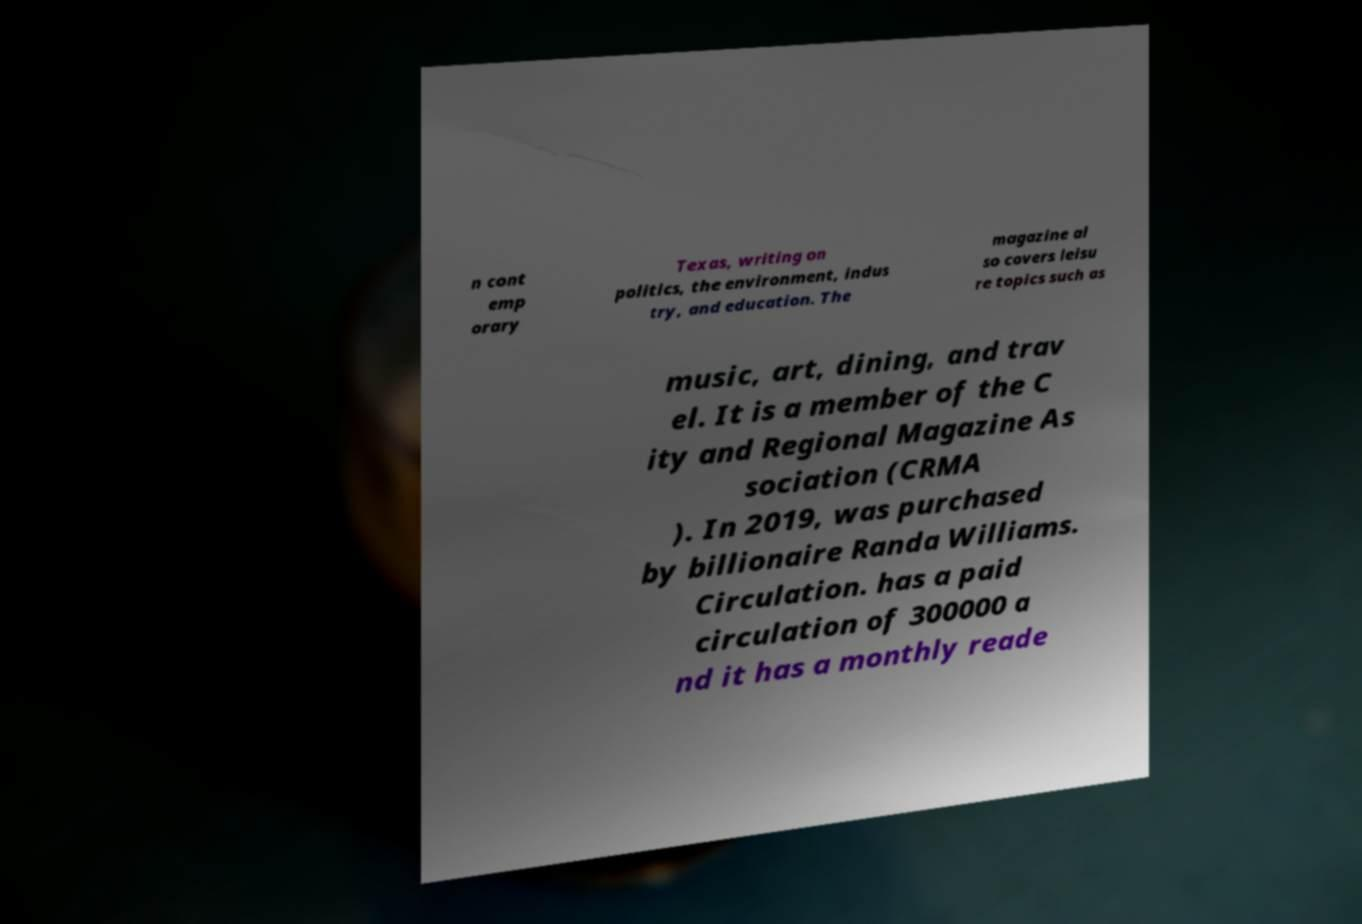Can you accurately transcribe the text from the provided image for me? n cont emp orary Texas, writing on politics, the environment, indus try, and education. The magazine al so covers leisu re topics such as music, art, dining, and trav el. It is a member of the C ity and Regional Magazine As sociation (CRMA ). In 2019, was purchased by billionaire Randa Williams. Circulation. has a paid circulation of 300000 a nd it has a monthly reade 